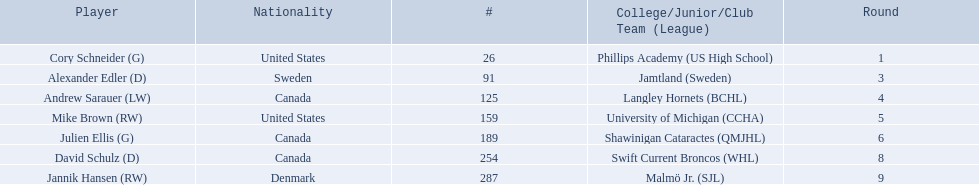What are the names of the colleges and jr leagues the players attended? Phillips Academy (US High School), Jamtland (Sweden), Langley Hornets (BCHL), University of Michigan (CCHA), Shawinigan Cataractes (QMJHL), Swift Current Broncos (WHL), Malmö Jr. (SJL). Which player played for the langley hornets? Andrew Sarauer (LW). 